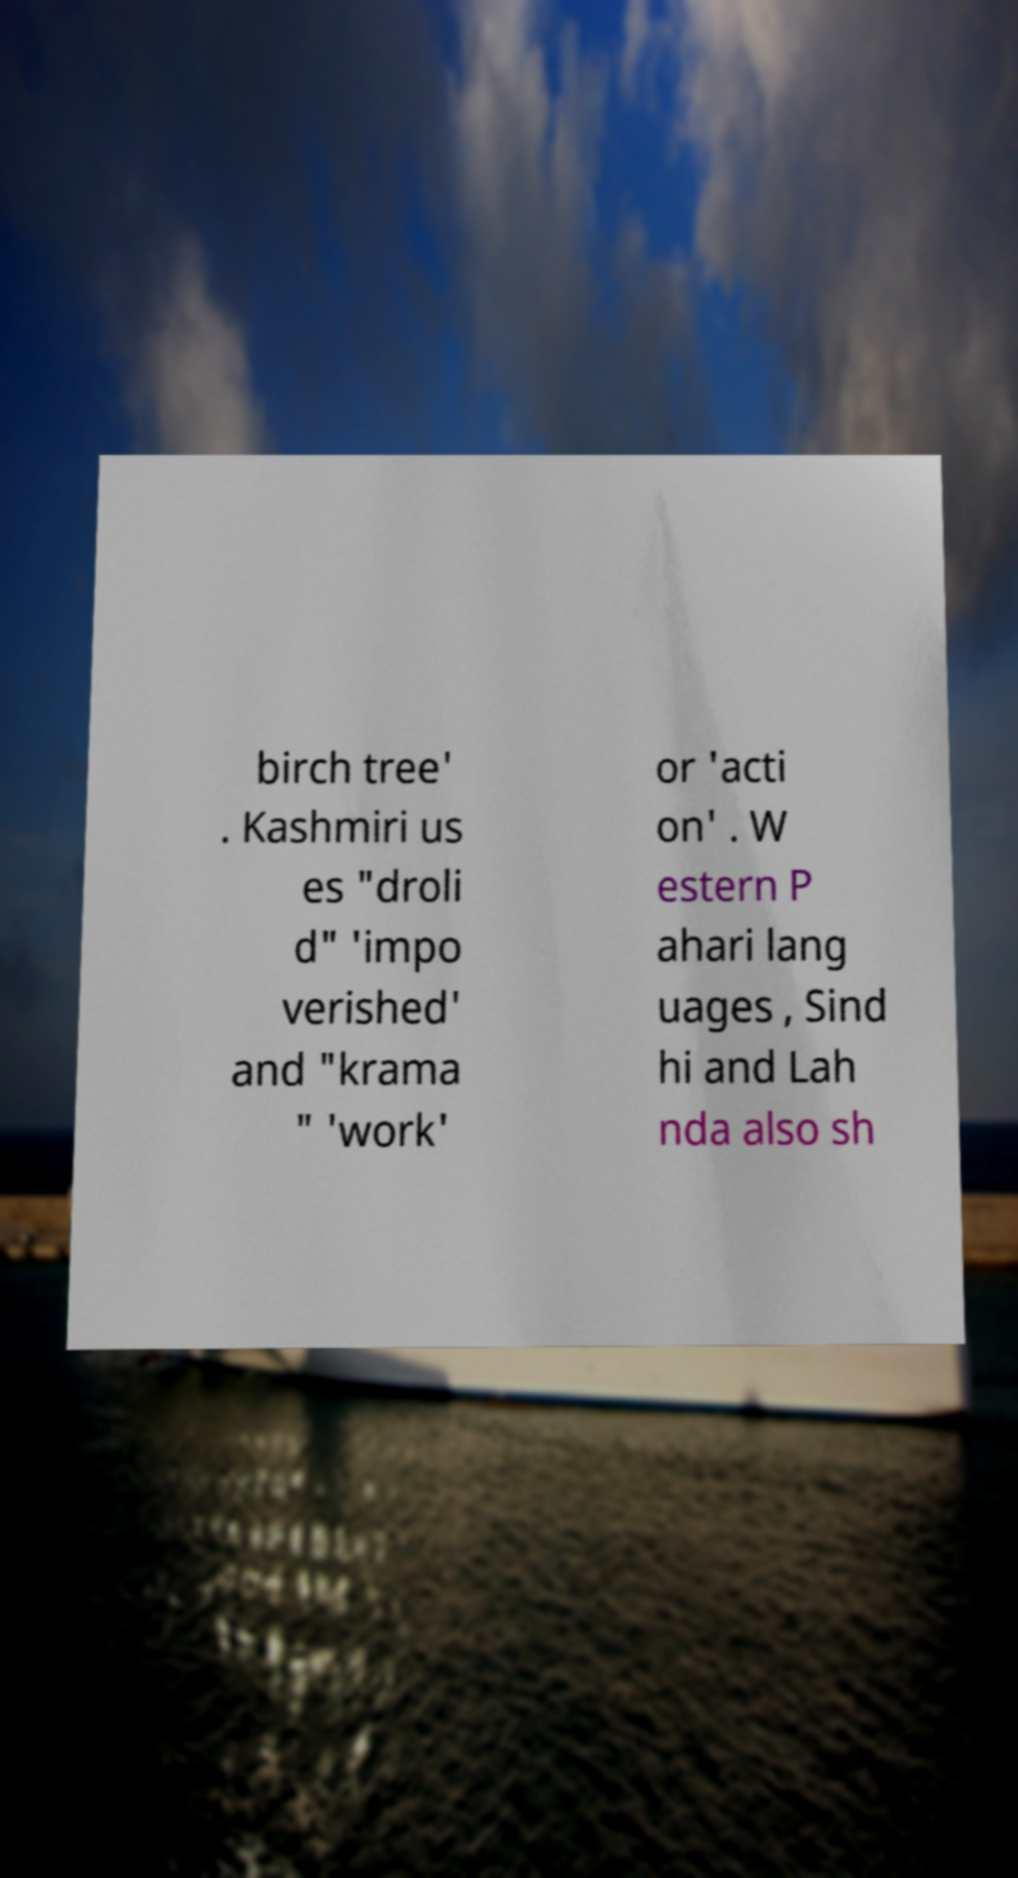Could you assist in decoding the text presented in this image and type it out clearly? birch tree' . Kashmiri us es "droli d" 'impo verished' and "krama " 'work' or 'acti on' . W estern P ahari lang uages , Sind hi and Lah nda also sh 